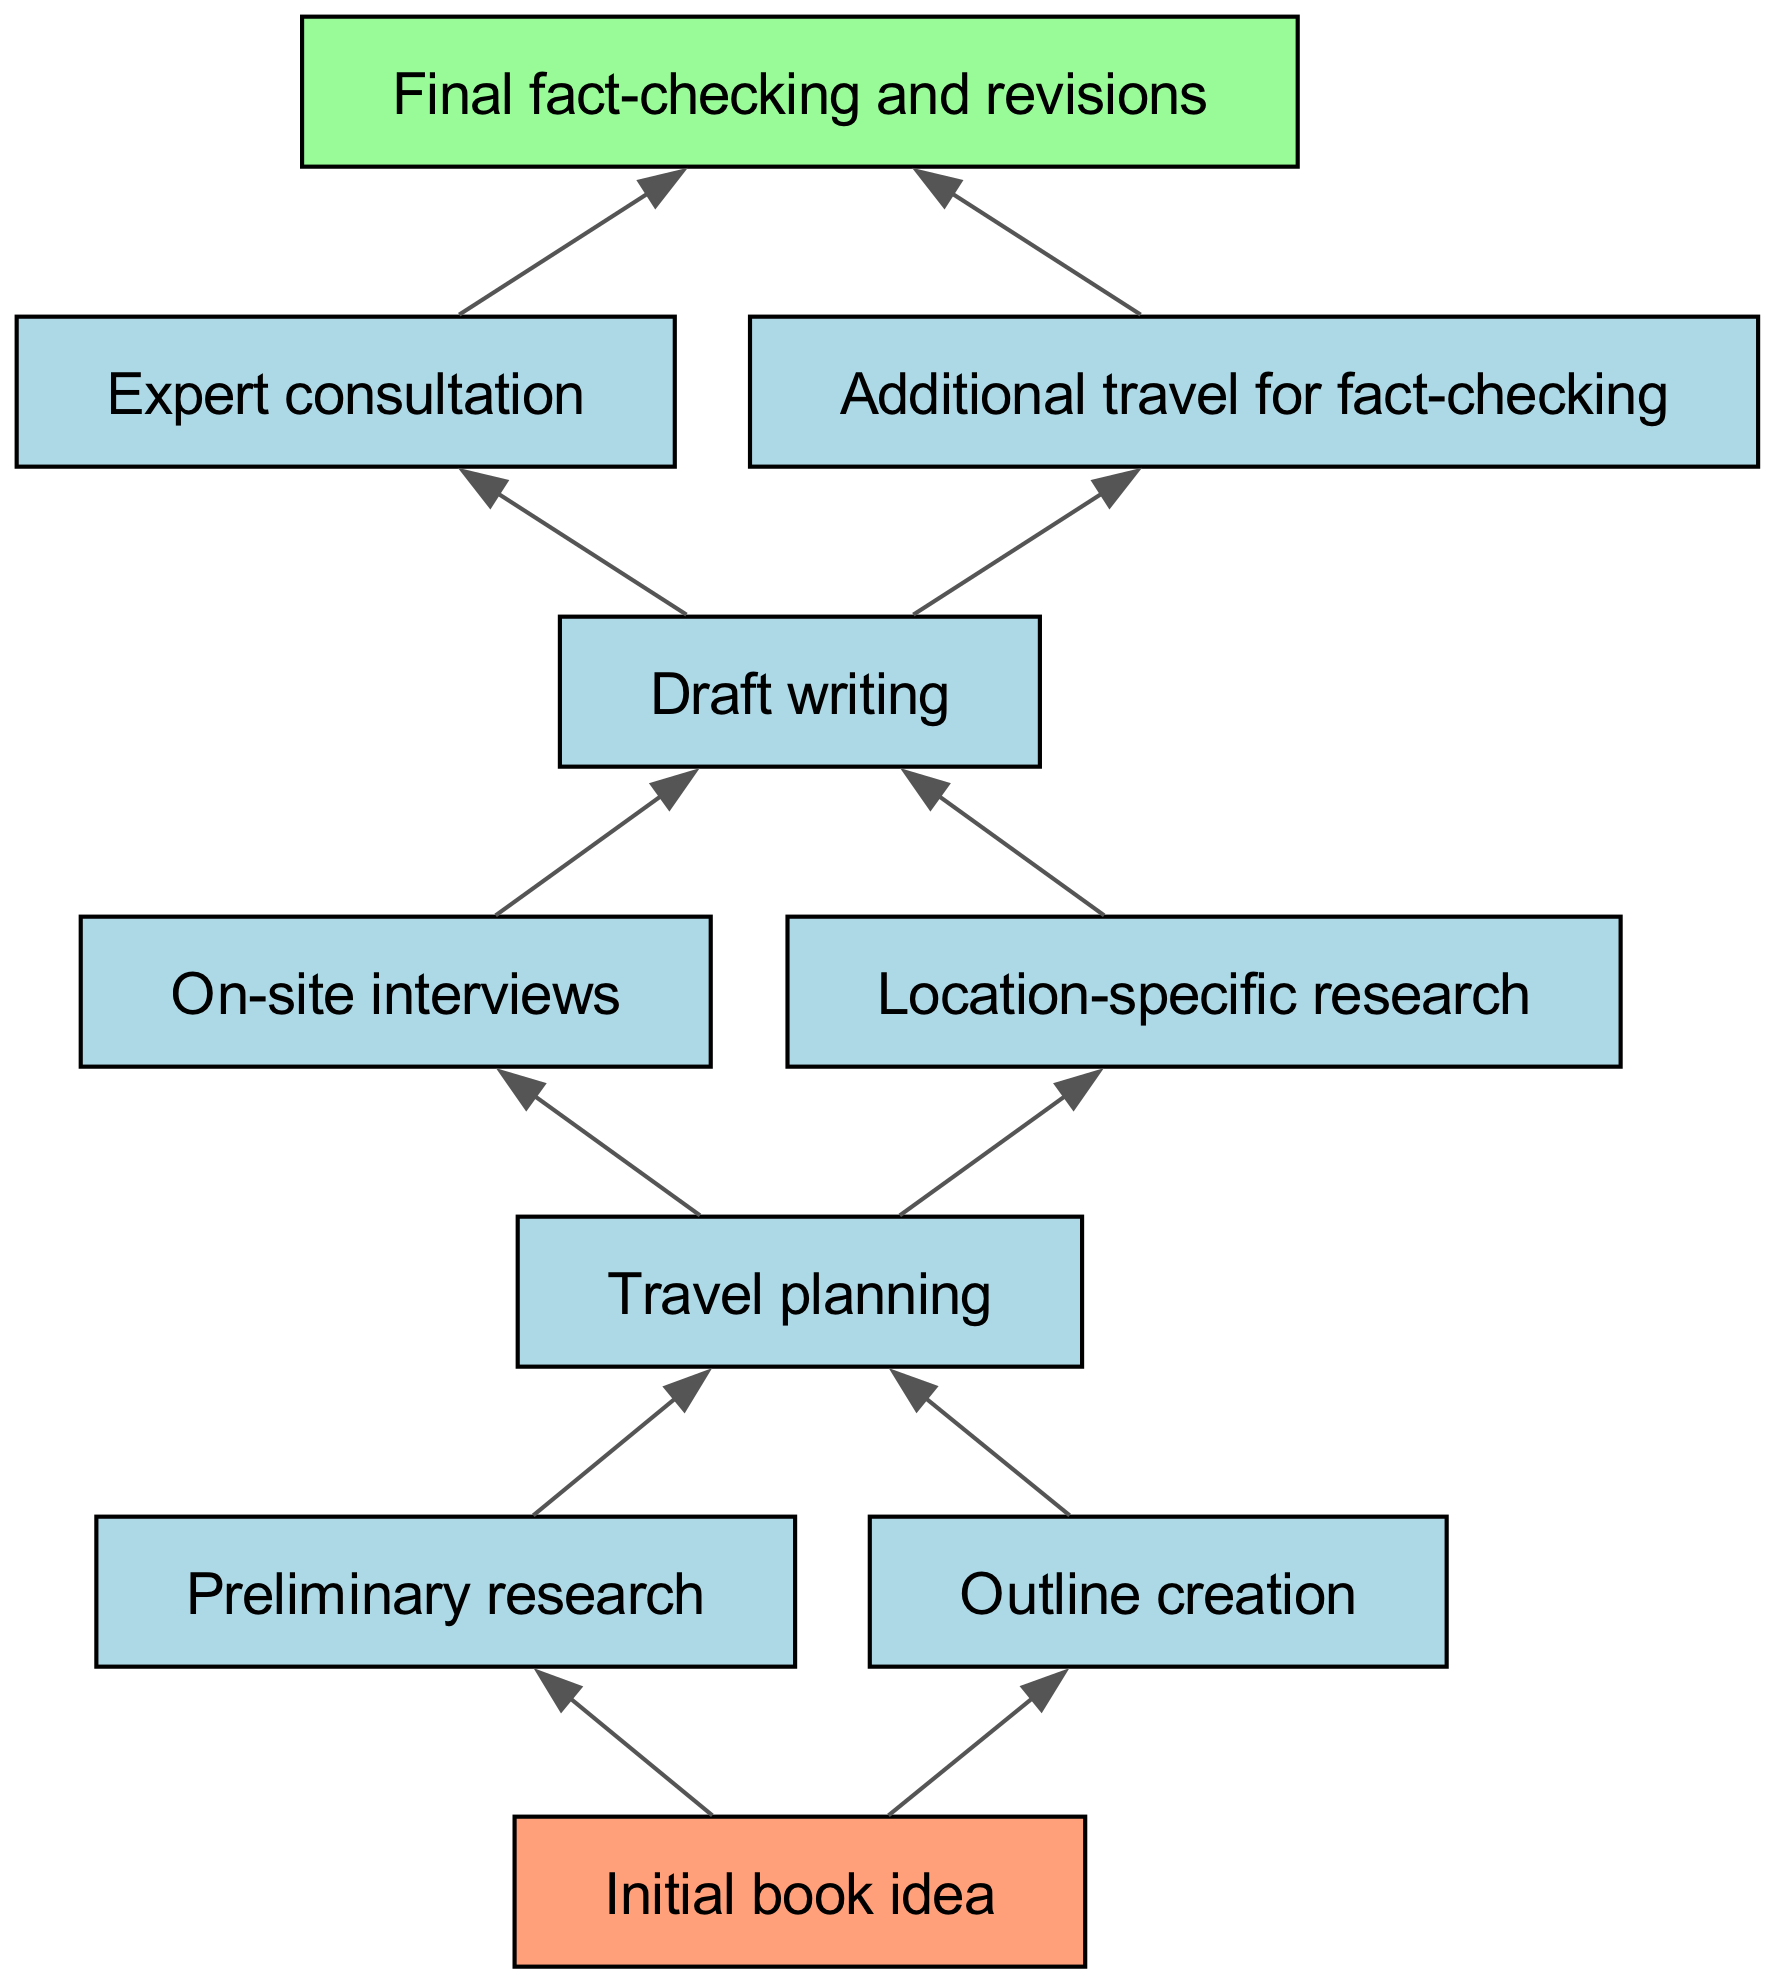What is the starting point of the research journey? The diagram starts with the node labeled "Initial book idea," which represents the beginning of the research process for the book.
Answer: Initial book idea How many connections does the "Draft writing" node have? The node "Draft writing" has two connections leading to "Expert consultation" and "Additional travel for fact-checking," indicating it is a central part of the research flow.
Answer: 2 What are the two activities that are part of the travel planning? The "Travel planning" node connects to "On-site interviews" and "Location-specific research," indicating these two activities relate to planning travel for research purposes.
Answer: On-site interviews, Location-specific research Which element comes immediately after "Outline creation"? The "Outline creation" node connects to the "Travel planning" node, which comes directly after it in the sequence of the research journey.
Answer: Travel planning What is the last step in the research journey? The final node in the diagram is "Final fact-checking and revisions," which signifies the last part of the research journey before publication.
Answer: Final fact-checking and revisions What is the relationship between "Preliminary research" and "Outline creation"? Both nodes connect to "Travel planning," showing that they are both prerequisites leading up to the travel planning stage in the research process.
Answer: They connect through Travel planning Is "Expert consultation" a prerequisite for "Final fact-checking and revisions"? Yes, "Expert consultation" must occur before "Final fact-checking and revisions" can take place, as denoted by the direct connection in the diagram.
Answer: Yes How many total nodes are there in the diagram? The diagram contains ten distinct nodes, each representing a specific step in the research journey for a non-fiction book.
Answer: 10 What types of activities are represented by the node "Location-specific research"? "Location-specific research" entails conducting research that is directly tied to a specific geographical area, implying focused data collection.
Answer: Focused data collection 